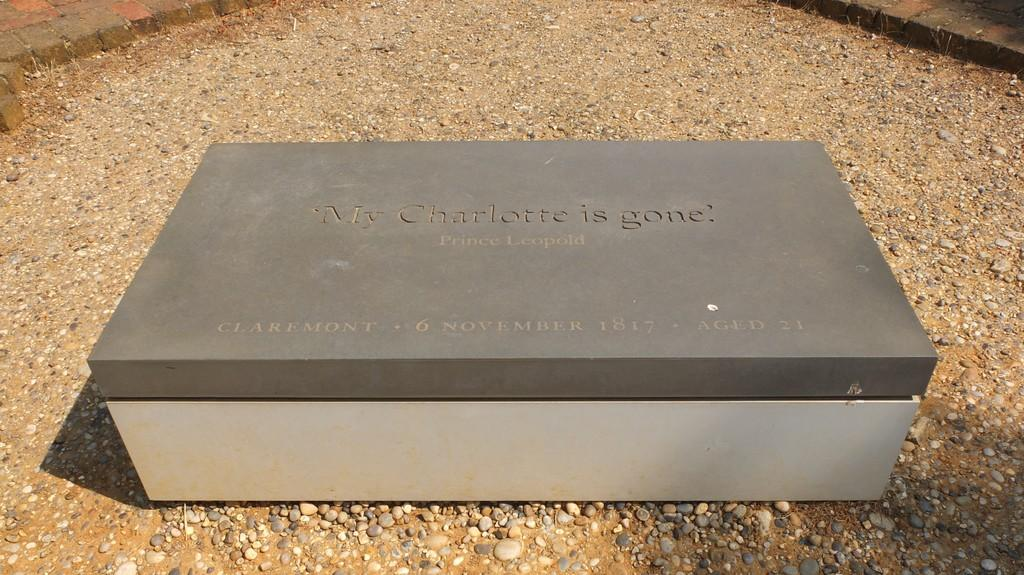<image>
Provide a brief description of the given image. Tomb or urn box on gravel with the epitaph My Charlotte is gone written on the slab. 